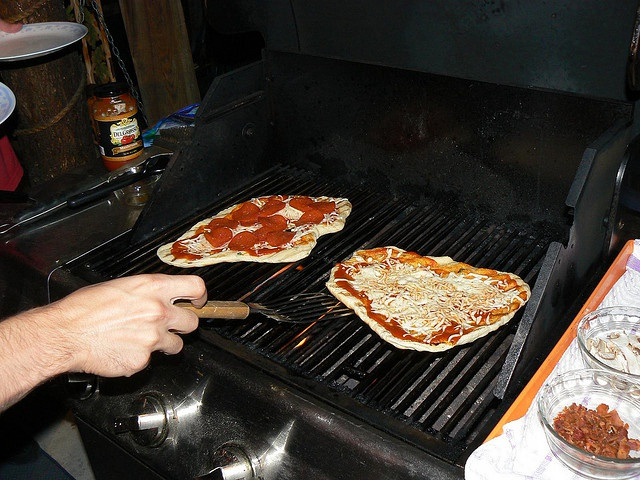Describe the objects in this image and their specific colors. I can see oven in black, gray, tan, and beige tones, people in black, tan, and gray tones, pizza in black, tan, beige, and brown tones, bowl in black, lightgray, darkgray, and brown tones, and pizza in black, maroon, tan, and brown tones in this image. 